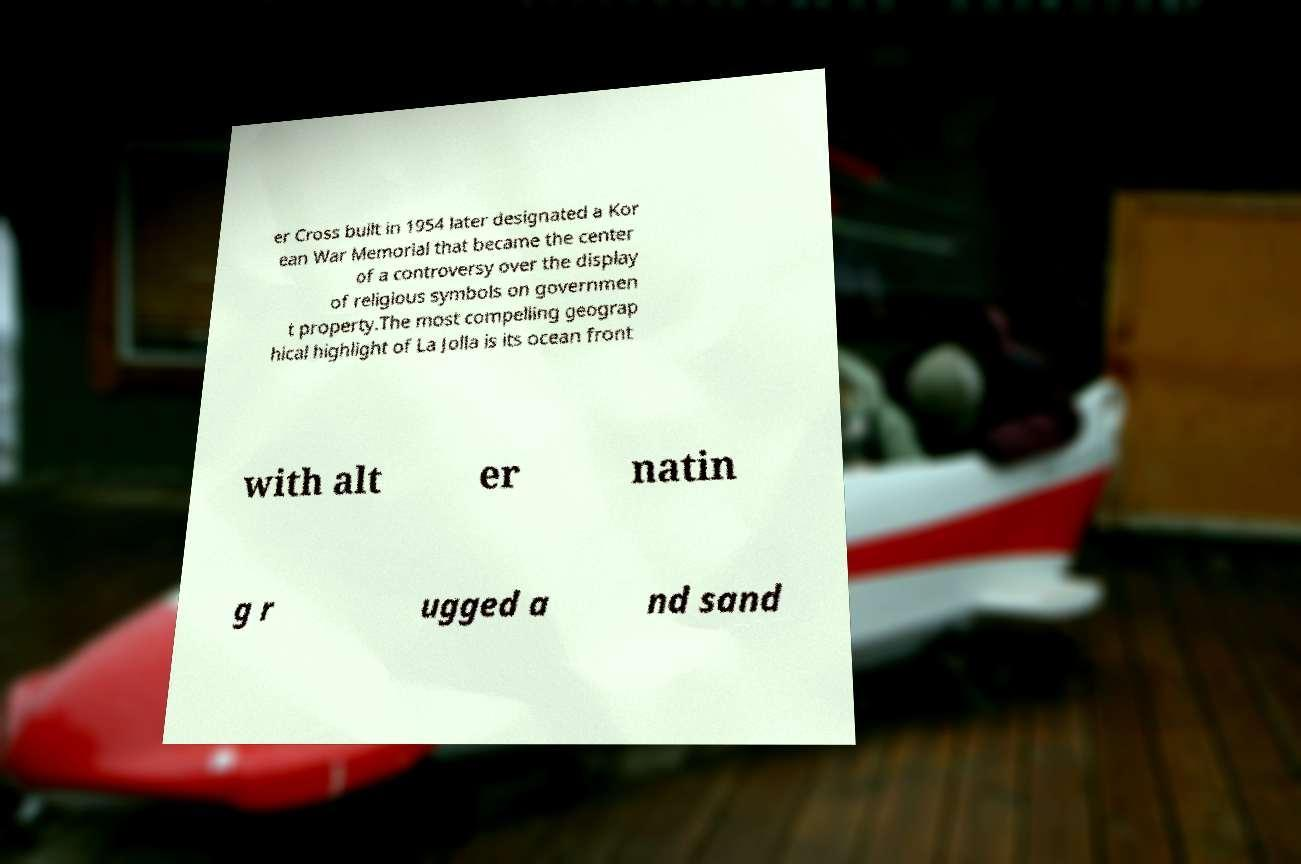Could you assist in decoding the text presented in this image and type it out clearly? er Cross built in 1954 later designated a Kor ean War Memorial that became the center of a controversy over the display of religious symbols on governmen t property.The most compelling geograp hical highlight of La Jolla is its ocean front with alt er natin g r ugged a nd sand 